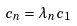<formula> <loc_0><loc_0><loc_500><loc_500>c _ { n } = \lambda _ { n } c _ { 1 }</formula> 